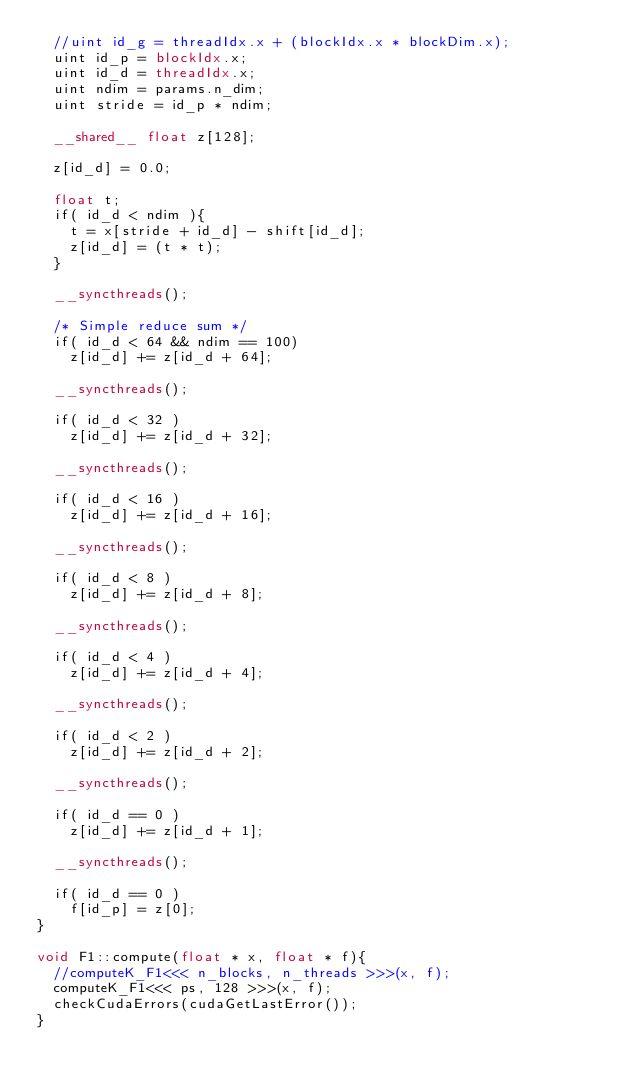Convert code to text. <code><loc_0><loc_0><loc_500><loc_500><_Cuda_>  //uint id_g = threadIdx.x + (blockIdx.x * blockDim.x);
  uint id_p = blockIdx.x;
  uint id_d = threadIdx.x;
  uint ndim = params.n_dim;
  uint stride = id_p * ndim;

  __shared__ float z[128];

  z[id_d] = 0.0;

  float t;
  if( id_d < ndim ){
    t = x[stride + id_d] - shift[id_d];
    z[id_d] = (t * t);
  }

  __syncthreads();

  /* Simple reduce sum */
  if( id_d < 64 && ndim == 100)
    z[id_d] += z[id_d + 64];

  __syncthreads();

  if( id_d < 32 )
    z[id_d] += z[id_d + 32];

  __syncthreads();

  if( id_d < 16 )
    z[id_d] += z[id_d + 16];

  __syncthreads();

  if( id_d < 8 )
    z[id_d] += z[id_d + 8];

  __syncthreads();

  if( id_d < 4 )
    z[id_d] += z[id_d + 4];

  __syncthreads();

  if( id_d < 2 )
    z[id_d] += z[id_d + 2];

  __syncthreads();

  if( id_d == 0 )
    z[id_d] += z[id_d + 1];

  __syncthreads();

  if( id_d == 0 )
    f[id_p] = z[0];
}

void F1::compute(float * x, float * f){
  //computeK_F1<<< n_blocks, n_threads >>>(x, f);
  computeK_F1<<< ps, 128 >>>(x, f);
  checkCudaErrors(cudaGetLastError());
}
</code> 